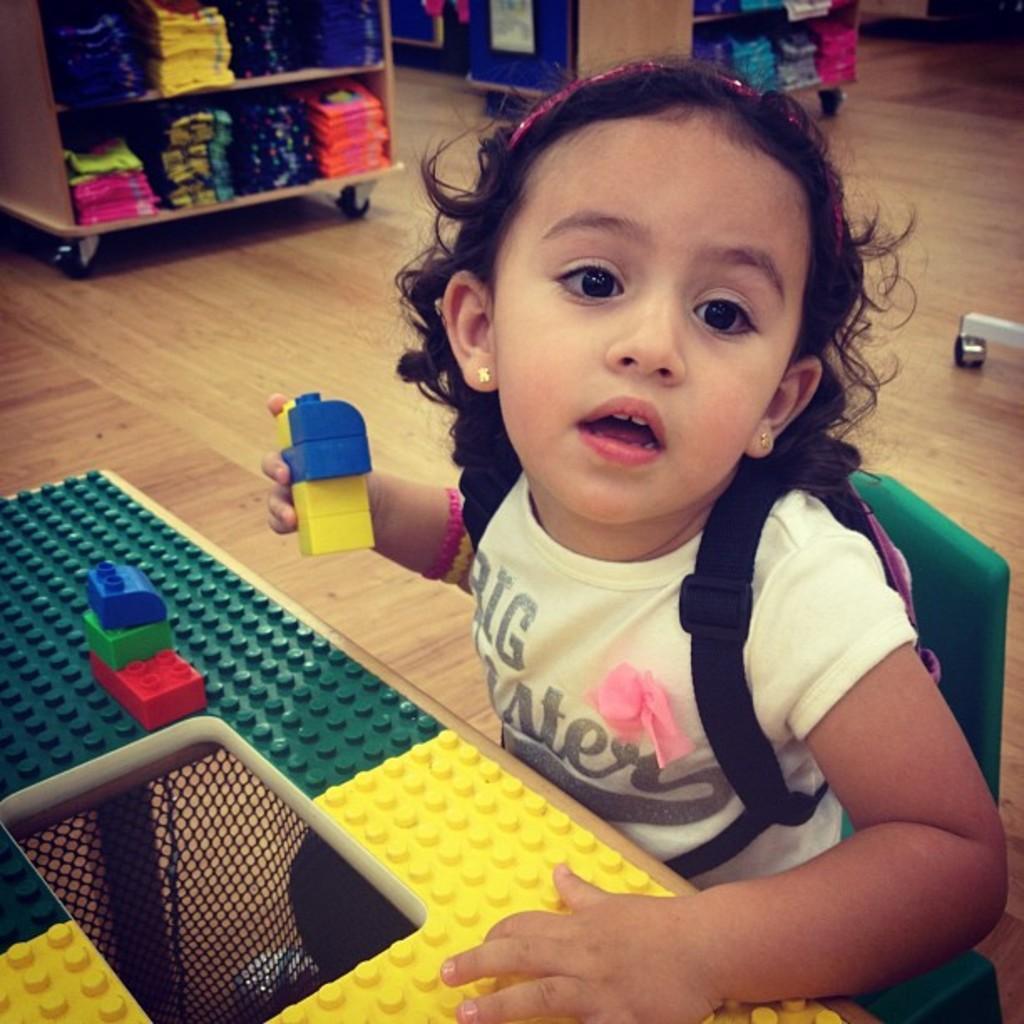In one or two sentences, can you explain what this image depicts? In the image we can see there is a girl sitting on the chair and carrying backpack at the back. She is holding blocks in her hand and on the table there are blocks. Behind there are clothes kept in racks. 